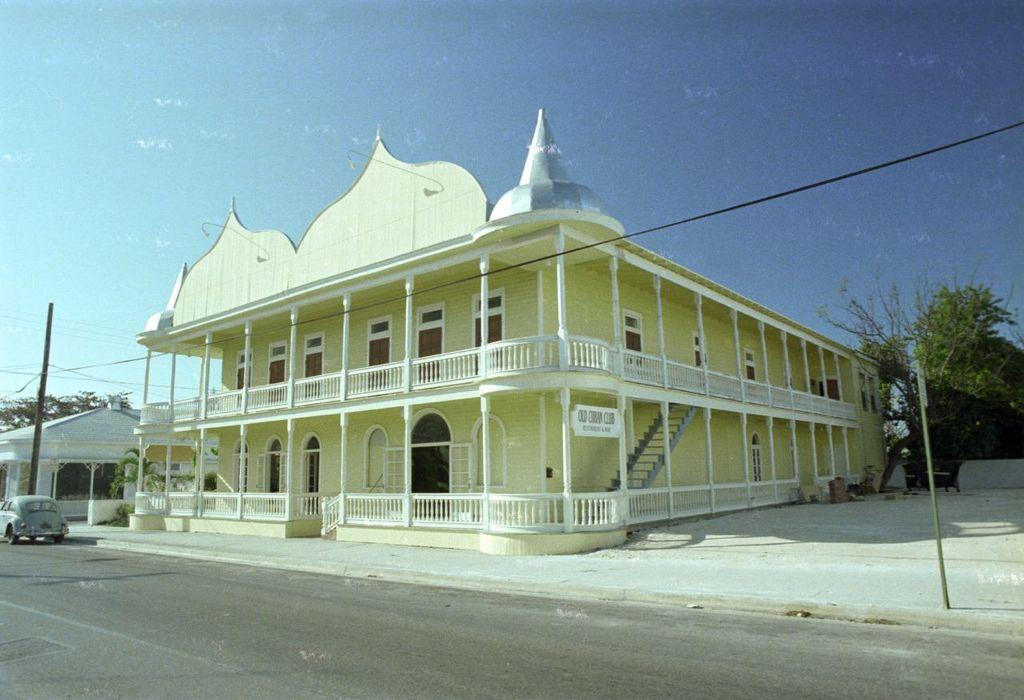What type of structures can be seen in the image? There are buildings in the image. What else can be seen in the image besides the buildings? There are poles with wires and a vehicle on the road in the image. What can be seen in the background of the image? Trees and the sky are visible in the background of the image. What type of hair can be seen on the aunt in the image? There is no aunt or hair present in the image. What territory is being claimed by the buildings in the image? The image does not indicate any territorial claims; it simply shows buildings, poles with wires, a vehicle, trees, and the sky. 